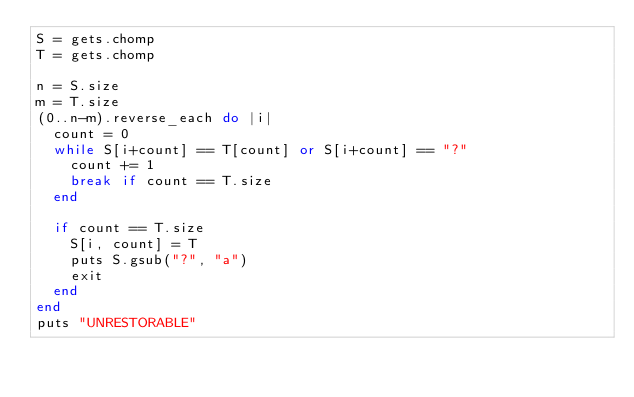<code> <loc_0><loc_0><loc_500><loc_500><_Ruby_>S = gets.chomp
T = gets.chomp

n = S.size
m = T.size
(0..n-m).reverse_each do |i|
  count = 0
  while S[i+count] == T[count] or S[i+count] == "?"
    count += 1
    break if count == T.size
  end
  
  if count == T.size
    S[i, count] = T
    puts S.gsub("?", "a")
    exit
  end
end
puts "UNRESTORABLE"</code> 